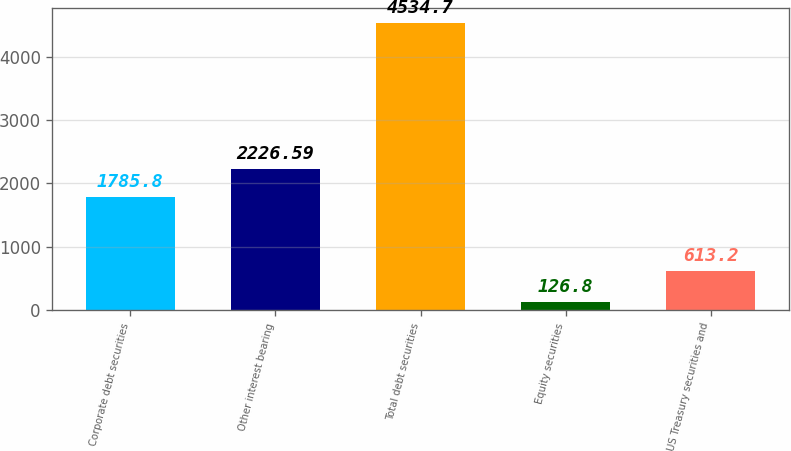Convert chart to OTSL. <chart><loc_0><loc_0><loc_500><loc_500><bar_chart><fcel>Corporate debt securities<fcel>Other interest bearing<fcel>Total debt securities<fcel>Equity securities<fcel>US Treasury securities and<nl><fcel>1785.8<fcel>2226.59<fcel>4534.7<fcel>126.8<fcel>613.2<nl></chart> 